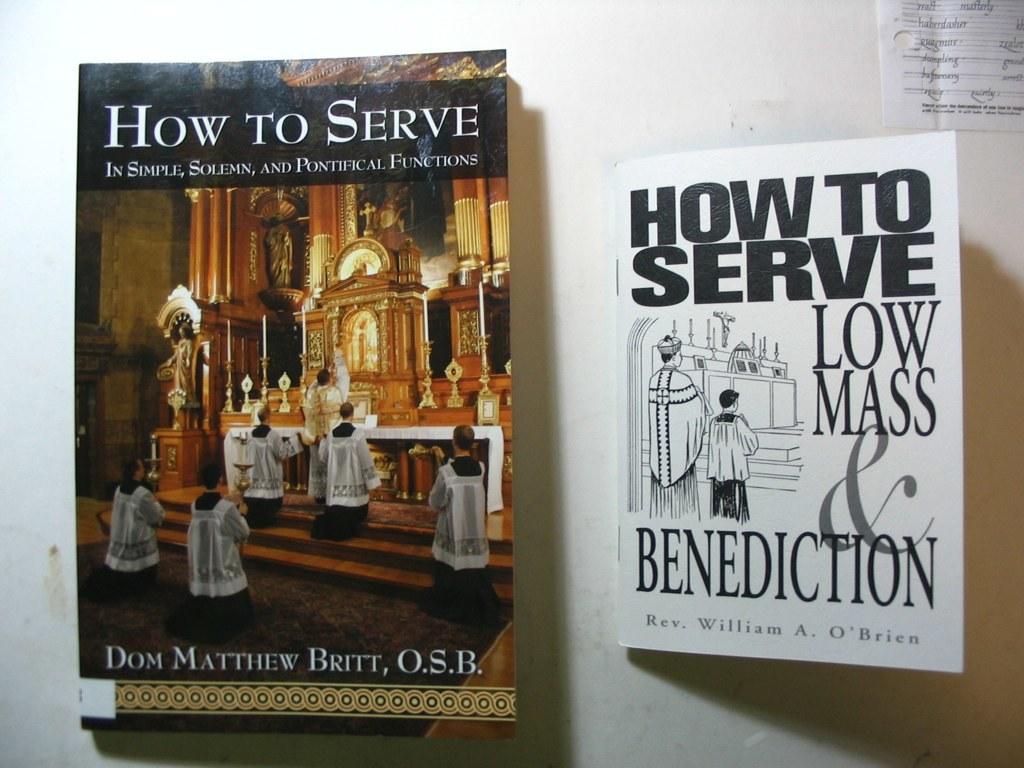What is the title of the white book?
Make the answer very short. How to serve low mass & benediction. Who wrote "how to serve?"?
Your answer should be compact. Dom matthew britt. 